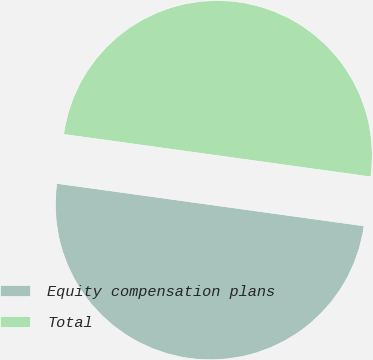<chart> <loc_0><loc_0><loc_500><loc_500><pie_chart><fcel>Equity compensation plans<fcel>Total<nl><fcel>50.0%<fcel>50.0%<nl></chart> 